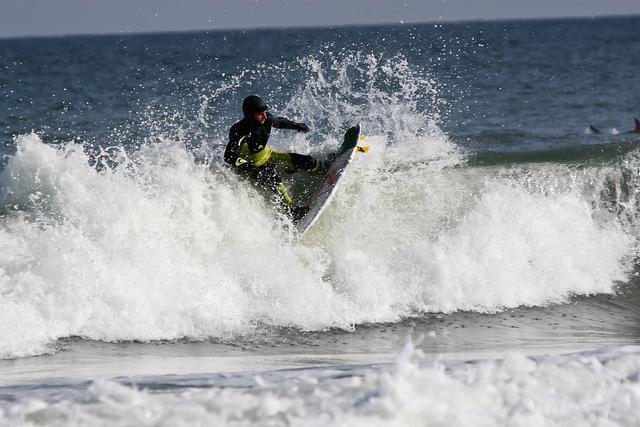How many people are surfing?
Quick response, please. 1. Do you see a sea creature in the background?
Concise answer only. Yes. Are there waves in the picture?
Answer briefly. Yes. 